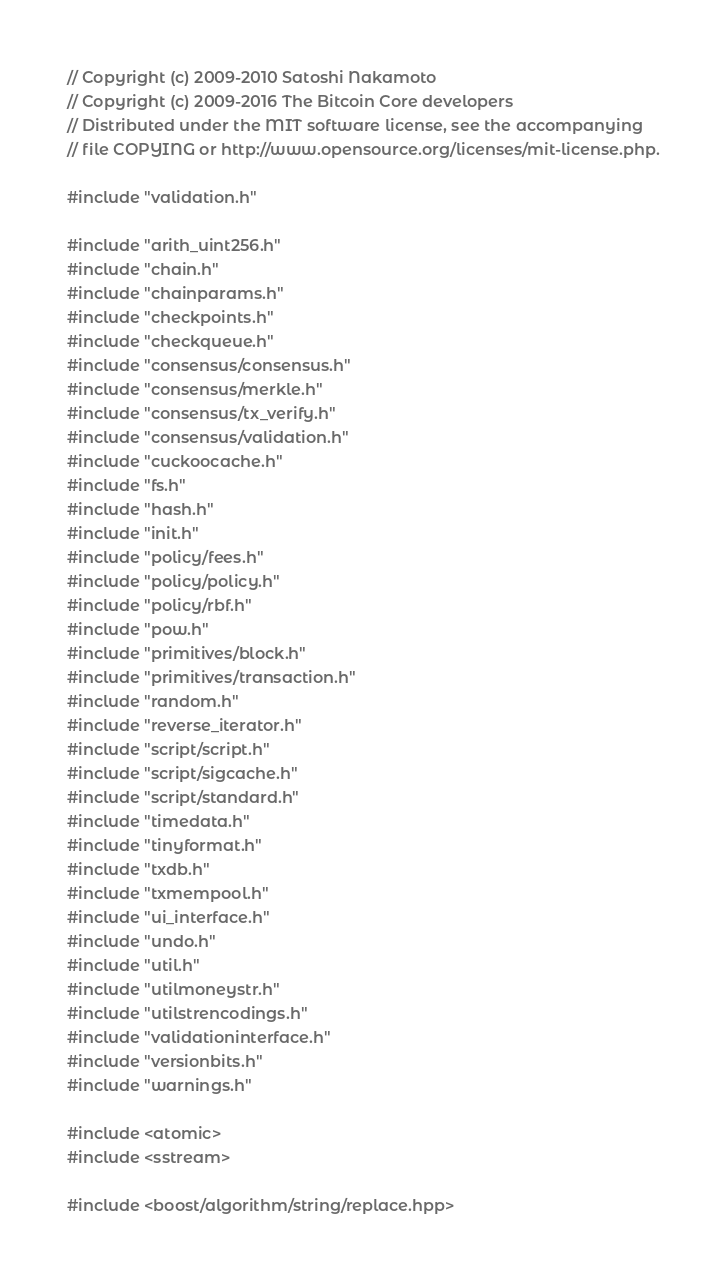<code> <loc_0><loc_0><loc_500><loc_500><_C++_>// Copyright (c) 2009-2010 Satoshi Nakamoto
// Copyright (c) 2009-2016 The Bitcoin Core developers
// Distributed under the MIT software license, see the accompanying
// file COPYING or http://www.opensource.org/licenses/mit-license.php.

#include "validation.h"

#include "arith_uint256.h"
#include "chain.h"
#include "chainparams.h"
#include "checkpoints.h"
#include "checkqueue.h"
#include "consensus/consensus.h"
#include "consensus/merkle.h"
#include "consensus/tx_verify.h"
#include "consensus/validation.h"
#include "cuckoocache.h"
#include "fs.h"
#include "hash.h"
#include "init.h"
#include "policy/fees.h"
#include "policy/policy.h"
#include "policy/rbf.h"
#include "pow.h"
#include "primitives/block.h"
#include "primitives/transaction.h"
#include "random.h"
#include "reverse_iterator.h"
#include "script/script.h"
#include "script/sigcache.h"
#include "script/standard.h"
#include "timedata.h"
#include "tinyformat.h"
#include "txdb.h"
#include "txmempool.h"
#include "ui_interface.h"
#include "undo.h"
#include "util.h"
#include "utilmoneystr.h"
#include "utilstrencodings.h"
#include "validationinterface.h"
#include "versionbits.h"
#include "warnings.h"

#include <atomic>
#include <sstream>

#include <boost/algorithm/string/replace.hpp></code> 